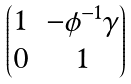<formula> <loc_0><loc_0><loc_500><loc_500>\begin{pmatrix} 1 & - \phi ^ { - 1 } \gamma \\ 0 & 1 \end{pmatrix}</formula> 